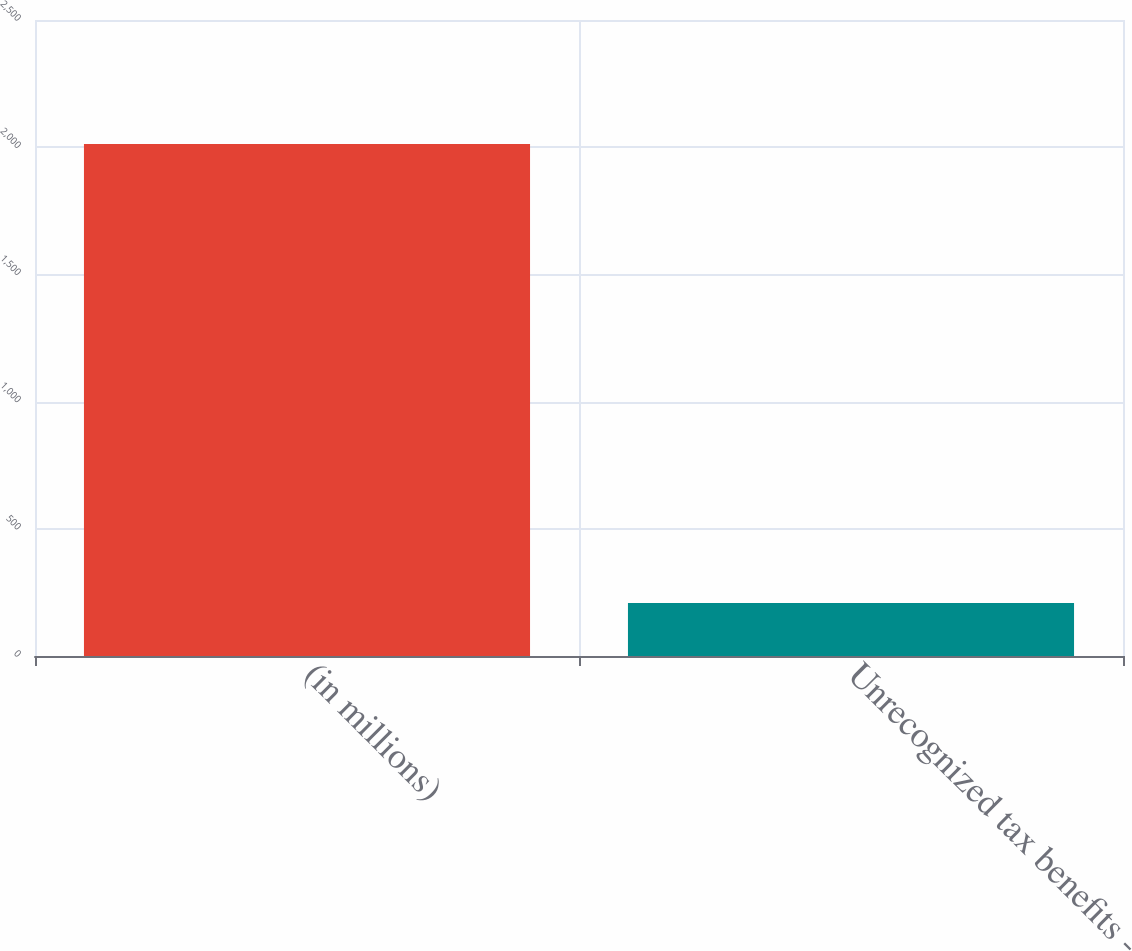Convert chart to OTSL. <chart><loc_0><loc_0><loc_500><loc_500><bar_chart><fcel>(in millions)<fcel>Unrecognized tax benefits -<nl><fcel>2013<fcel>208.5<nl></chart> 